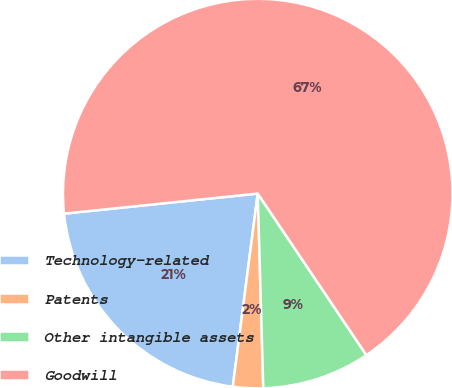<chart> <loc_0><loc_0><loc_500><loc_500><pie_chart><fcel>Technology-related<fcel>Patents<fcel>Other intangible assets<fcel>Goodwill<nl><fcel>21.31%<fcel>2.5%<fcel>8.97%<fcel>67.22%<nl></chart> 